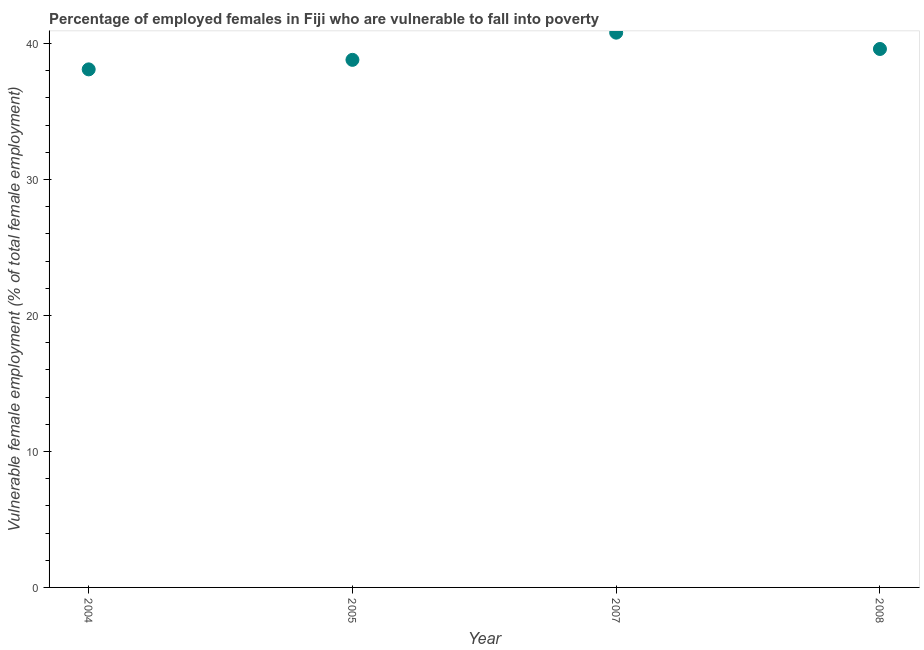What is the percentage of employed females who are vulnerable to fall into poverty in 2008?
Provide a succinct answer. 39.6. Across all years, what is the maximum percentage of employed females who are vulnerable to fall into poverty?
Provide a short and direct response. 40.8. Across all years, what is the minimum percentage of employed females who are vulnerable to fall into poverty?
Give a very brief answer. 38.1. In which year was the percentage of employed females who are vulnerable to fall into poverty maximum?
Ensure brevity in your answer.  2007. In which year was the percentage of employed females who are vulnerable to fall into poverty minimum?
Offer a very short reply. 2004. What is the sum of the percentage of employed females who are vulnerable to fall into poverty?
Your answer should be very brief. 157.3. What is the difference between the percentage of employed females who are vulnerable to fall into poverty in 2004 and 2005?
Your answer should be compact. -0.7. What is the average percentage of employed females who are vulnerable to fall into poverty per year?
Offer a very short reply. 39.32. What is the median percentage of employed females who are vulnerable to fall into poverty?
Your answer should be very brief. 39.2. In how many years, is the percentage of employed females who are vulnerable to fall into poverty greater than 18 %?
Ensure brevity in your answer.  4. What is the ratio of the percentage of employed females who are vulnerable to fall into poverty in 2005 to that in 2007?
Your answer should be compact. 0.95. Is the percentage of employed females who are vulnerable to fall into poverty in 2005 less than that in 2008?
Your response must be concise. Yes. What is the difference between the highest and the second highest percentage of employed females who are vulnerable to fall into poverty?
Your response must be concise. 1.2. Is the sum of the percentage of employed females who are vulnerable to fall into poverty in 2005 and 2008 greater than the maximum percentage of employed females who are vulnerable to fall into poverty across all years?
Offer a terse response. Yes. What is the difference between the highest and the lowest percentage of employed females who are vulnerable to fall into poverty?
Keep it short and to the point. 2.7. In how many years, is the percentage of employed females who are vulnerable to fall into poverty greater than the average percentage of employed females who are vulnerable to fall into poverty taken over all years?
Make the answer very short. 2. Does the percentage of employed females who are vulnerable to fall into poverty monotonically increase over the years?
Offer a very short reply. No. How many dotlines are there?
Make the answer very short. 1. How many years are there in the graph?
Your answer should be compact. 4. Does the graph contain any zero values?
Give a very brief answer. No. Does the graph contain grids?
Make the answer very short. No. What is the title of the graph?
Your response must be concise. Percentage of employed females in Fiji who are vulnerable to fall into poverty. What is the label or title of the X-axis?
Offer a very short reply. Year. What is the label or title of the Y-axis?
Offer a terse response. Vulnerable female employment (% of total female employment). What is the Vulnerable female employment (% of total female employment) in 2004?
Keep it short and to the point. 38.1. What is the Vulnerable female employment (% of total female employment) in 2005?
Ensure brevity in your answer.  38.8. What is the Vulnerable female employment (% of total female employment) in 2007?
Your answer should be very brief. 40.8. What is the Vulnerable female employment (% of total female employment) in 2008?
Offer a very short reply. 39.6. What is the difference between the Vulnerable female employment (% of total female employment) in 2004 and 2005?
Keep it short and to the point. -0.7. What is the difference between the Vulnerable female employment (% of total female employment) in 2005 and 2007?
Make the answer very short. -2. What is the difference between the Vulnerable female employment (% of total female employment) in 2005 and 2008?
Give a very brief answer. -0.8. What is the ratio of the Vulnerable female employment (% of total female employment) in 2004 to that in 2005?
Keep it short and to the point. 0.98. What is the ratio of the Vulnerable female employment (% of total female employment) in 2004 to that in 2007?
Offer a very short reply. 0.93. What is the ratio of the Vulnerable female employment (% of total female employment) in 2005 to that in 2007?
Provide a succinct answer. 0.95. What is the ratio of the Vulnerable female employment (% of total female employment) in 2005 to that in 2008?
Give a very brief answer. 0.98. What is the ratio of the Vulnerable female employment (% of total female employment) in 2007 to that in 2008?
Your answer should be compact. 1.03. 